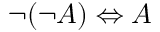<formula> <loc_0><loc_0><loc_500><loc_500>\neg ( \neg A ) \Leftrightarrow A</formula> 